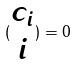<formula> <loc_0><loc_0><loc_500><loc_500>( \begin{matrix} c _ { i } \\ i \end{matrix} ) = 0</formula> 